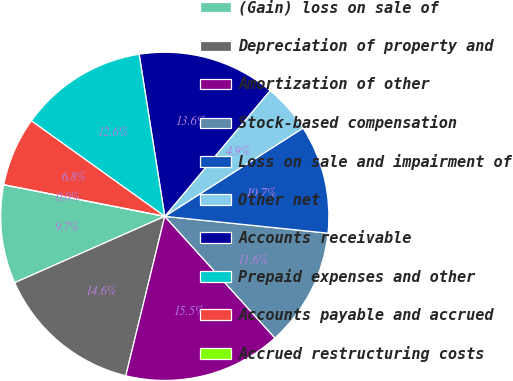<chart> <loc_0><loc_0><loc_500><loc_500><pie_chart><fcel>(Gain) loss on sale of<fcel>Depreciation of property and<fcel>Amortization of other<fcel>Stock-based compensation<fcel>Loss on sale and impairment of<fcel>Other net<fcel>Accounts receivable<fcel>Prepaid expenses and other<fcel>Accounts payable and accrued<fcel>Accrued restructuring costs<nl><fcel>9.71%<fcel>14.56%<fcel>15.53%<fcel>11.65%<fcel>10.68%<fcel>4.86%<fcel>13.59%<fcel>12.62%<fcel>6.8%<fcel>0.0%<nl></chart> 